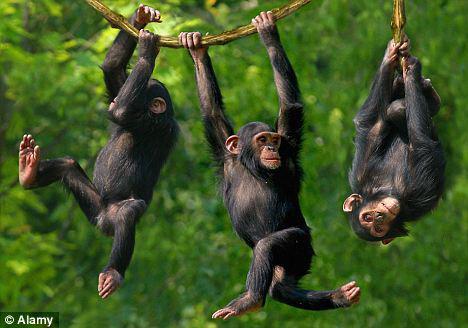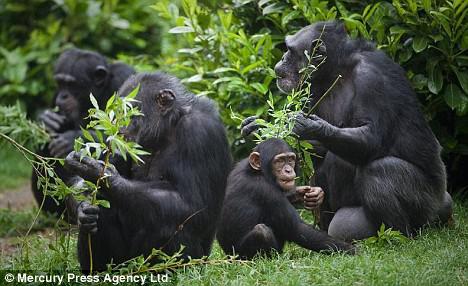The first image is the image on the left, the second image is the image on the right. Assess this claim about the two images: "Some apes are holding food in their hands.". Correct or not? Answer yes or no. Yes. The first image is the image on the left, the second image is the image on the right. Assess this claim about the two images: "An image shows a trio of chimps in a row up off the ground on something branch-like.". Correct or not? Answer yes or no. Yes. 